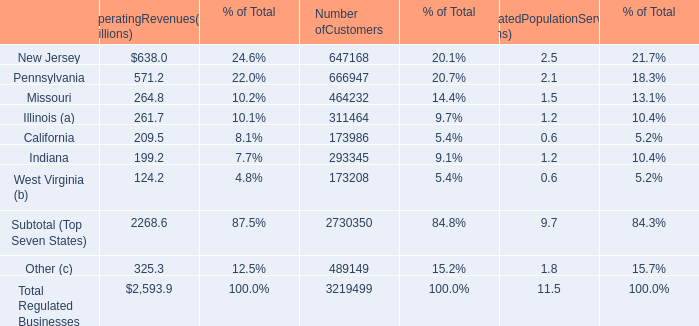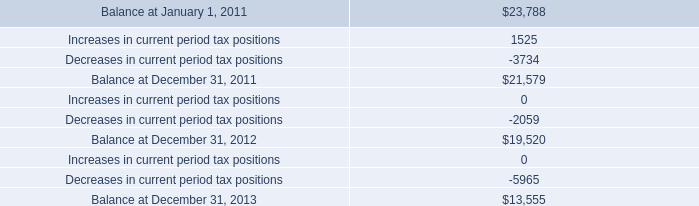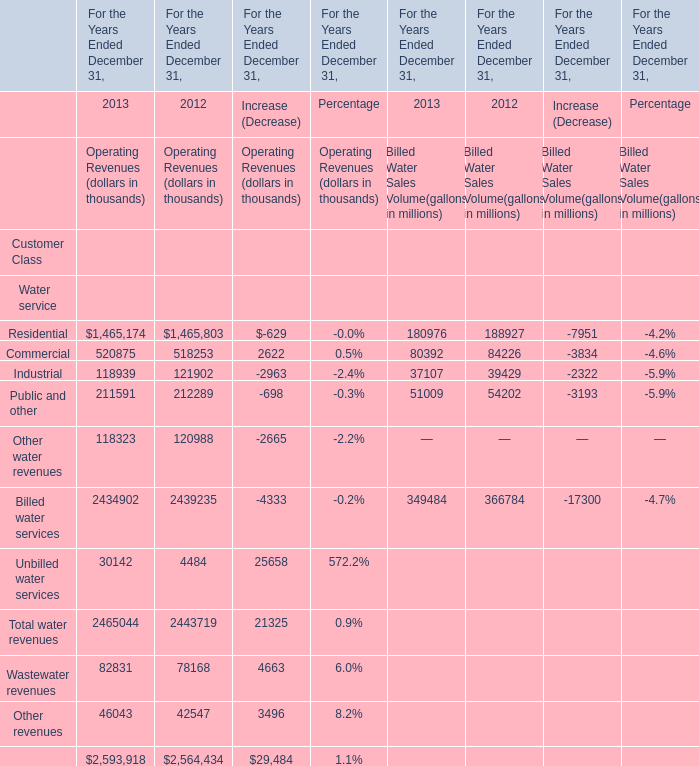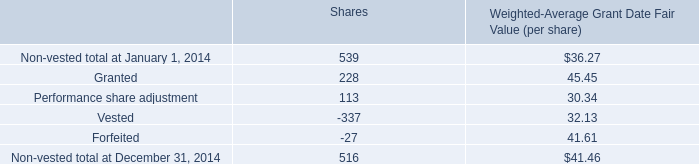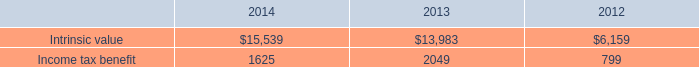What is the growing rate of Intrinsic value in Table 4 in the year with the most Commercial of Operating Revenues in Table 2? 
Computations: ((13983 - 6159) / 6159)
Answer: 1.27034. 